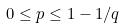Convert formula to latex. <formula><loc_0><loc_0><loc_500><loc_500>0 \leq p \leq 1 - 1 / q</formula> 